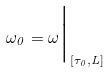<formula> <loc_0><loc_0><loc_500><loc_500>\omega _ { 0 } = \omega \Big | _ { [ \tau _ { 0 } , L ] }</formula> 